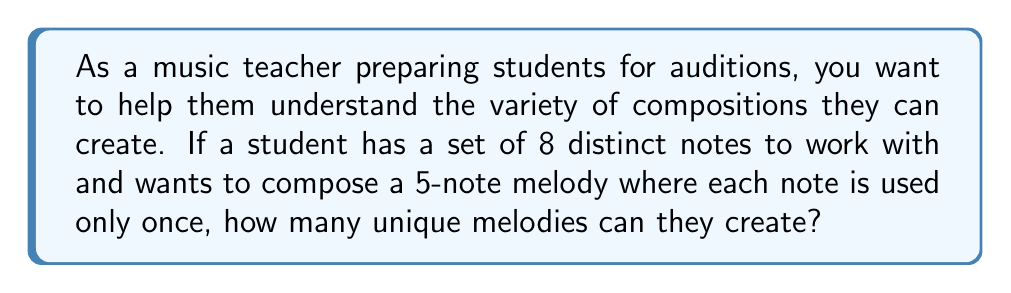Provide a solution to this math problem. Let's approach this step-by-step:

1) This is a permutation problem because the order of the notes matters in a melody, and we're selecting notes without replacement (each note is used only once).

2) We are choosing 5 notes out of 8 available notes, and the order matters.

3) The formula for permutations is:

   $$P(n,r) = \frac{n!}{(n-r)!}$$

   Where $n$ is the total number of items to choose from, and $r$ is the number of items being chosen.

4) In this case, $n = 8$ (total notes available) and $r = 5$ (notes in the melody).

5) Plugging these values into our formula:

   $$P(8,5) = \frac{8!}{(8-5)!} = \frac{8!}{3!}$$

6) Let's calculate this:
   
   $$\frac{8!}{3!} = \frac{8 \times 7 \times 6 \times 5 \times 4 \times 3!}{3!}$$

7) The $3!$ cancels out in the numerator and denominator:

   $$8 \times 7 \times 6 \times 5 \times 4 = 6720$$

Therefore, the student can create 6720 unique 5-note melodies using the given set of 8 notes.
Answer: 6720 unique melodies 